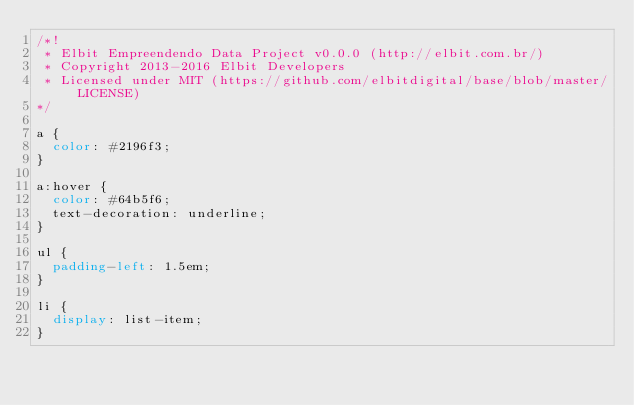Convert code to text. <code><loc_0><loc_0><loc_500><loc_500><_CSS_>/*!
 * Elbit Empreendendo Data Project v0.0.0 (http://elbit.com.br/)
 * Copyright 2013-2016 Elbit Developers
 * Licensed under MIT (https://github.com/elbitdigital/base/blob/master/LICENSE)
*/

a {
  color: #2196f3;
}

a:hover {
  color: #64b5f6;
  text-decoration: underline;
}

ul {
  padding-left: 1.5em;
}

li {
  display: list-item;
}</code> 